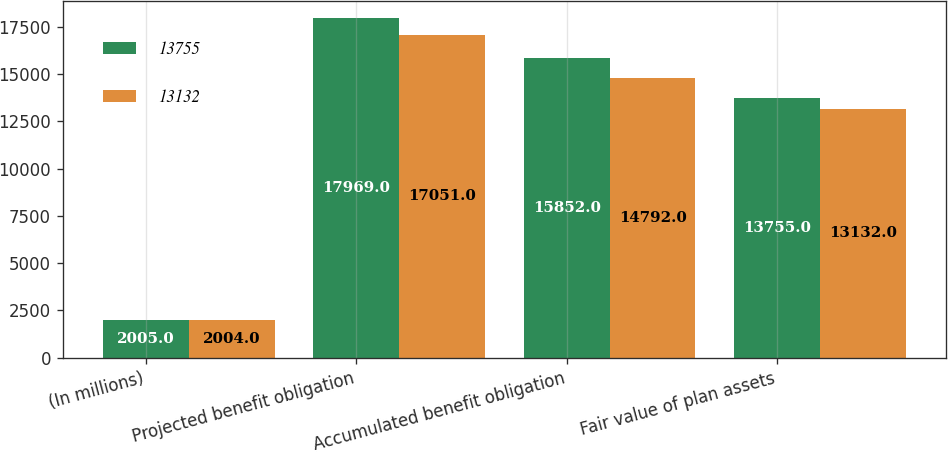Convert chart to OTSL. <chart><loc_0><loc_0><loc_500><loc_500><stacked_bar_chart><ecel><fcel>(In millions)<fcel>Projected benefit obligation<fcel>Accumulated benefit obligation<fcel>Fair value of plan assets<nl><fcel>13755<fcel>2005<fcel>17969<fcel>15852<fcel>13755<nl><fcel>13132<fcel>2004<fcel>17051<fcel>14792<fcel>13132<nl></chart> 